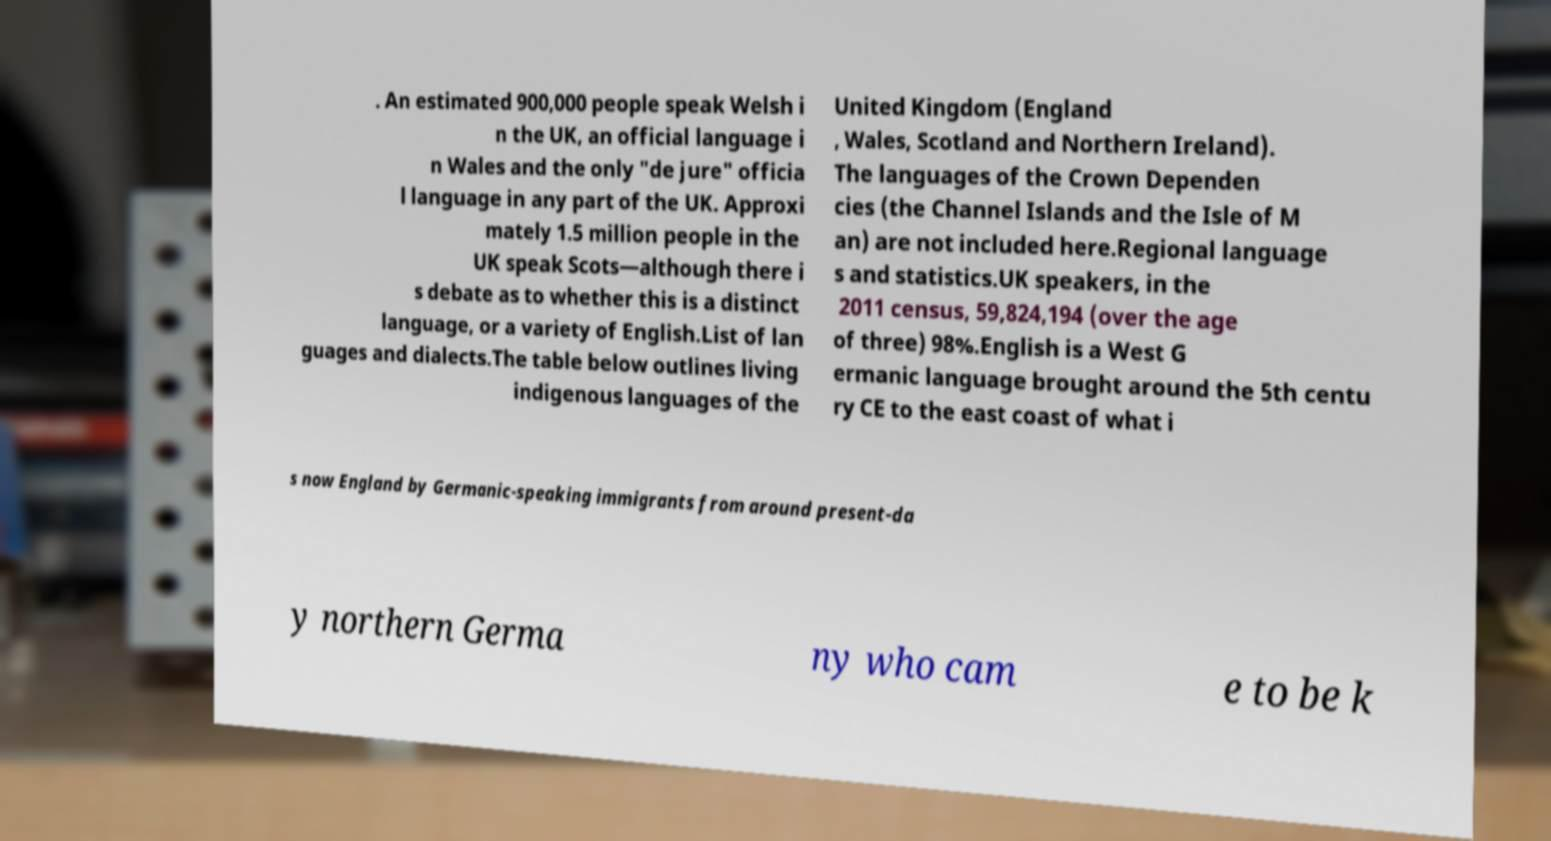Could you assist in decoding the text presented in this image and type it out clearly? . An estimated 900,000 people speak Welsh i n the UK, an official language i n Wales and the only "de jure" officia l language in any part of the UK. Approxi mately 1.5 million people in the UK speak Scots—although there i s debate as to whether this is a distinct language, or a variety of English.List of lan guages and dialects.The table below outlines living indigenous languages of the United Kingdom (England , Wales, Scotland and Northern Ireland). The languages of the Crown Dependen cies (the Channel Islands and the Isle of M an) are not included here.Regional language s and statistics.UK speakers, in the 2011 census, 59,824,194 (over the age of three) 98%.English is a West G ermanic language brought around the 5th centu ry CE to the east coast of what i s now England by Germanic-speaking immigrants from around present-da y northern Germa ny who cam e to be k 